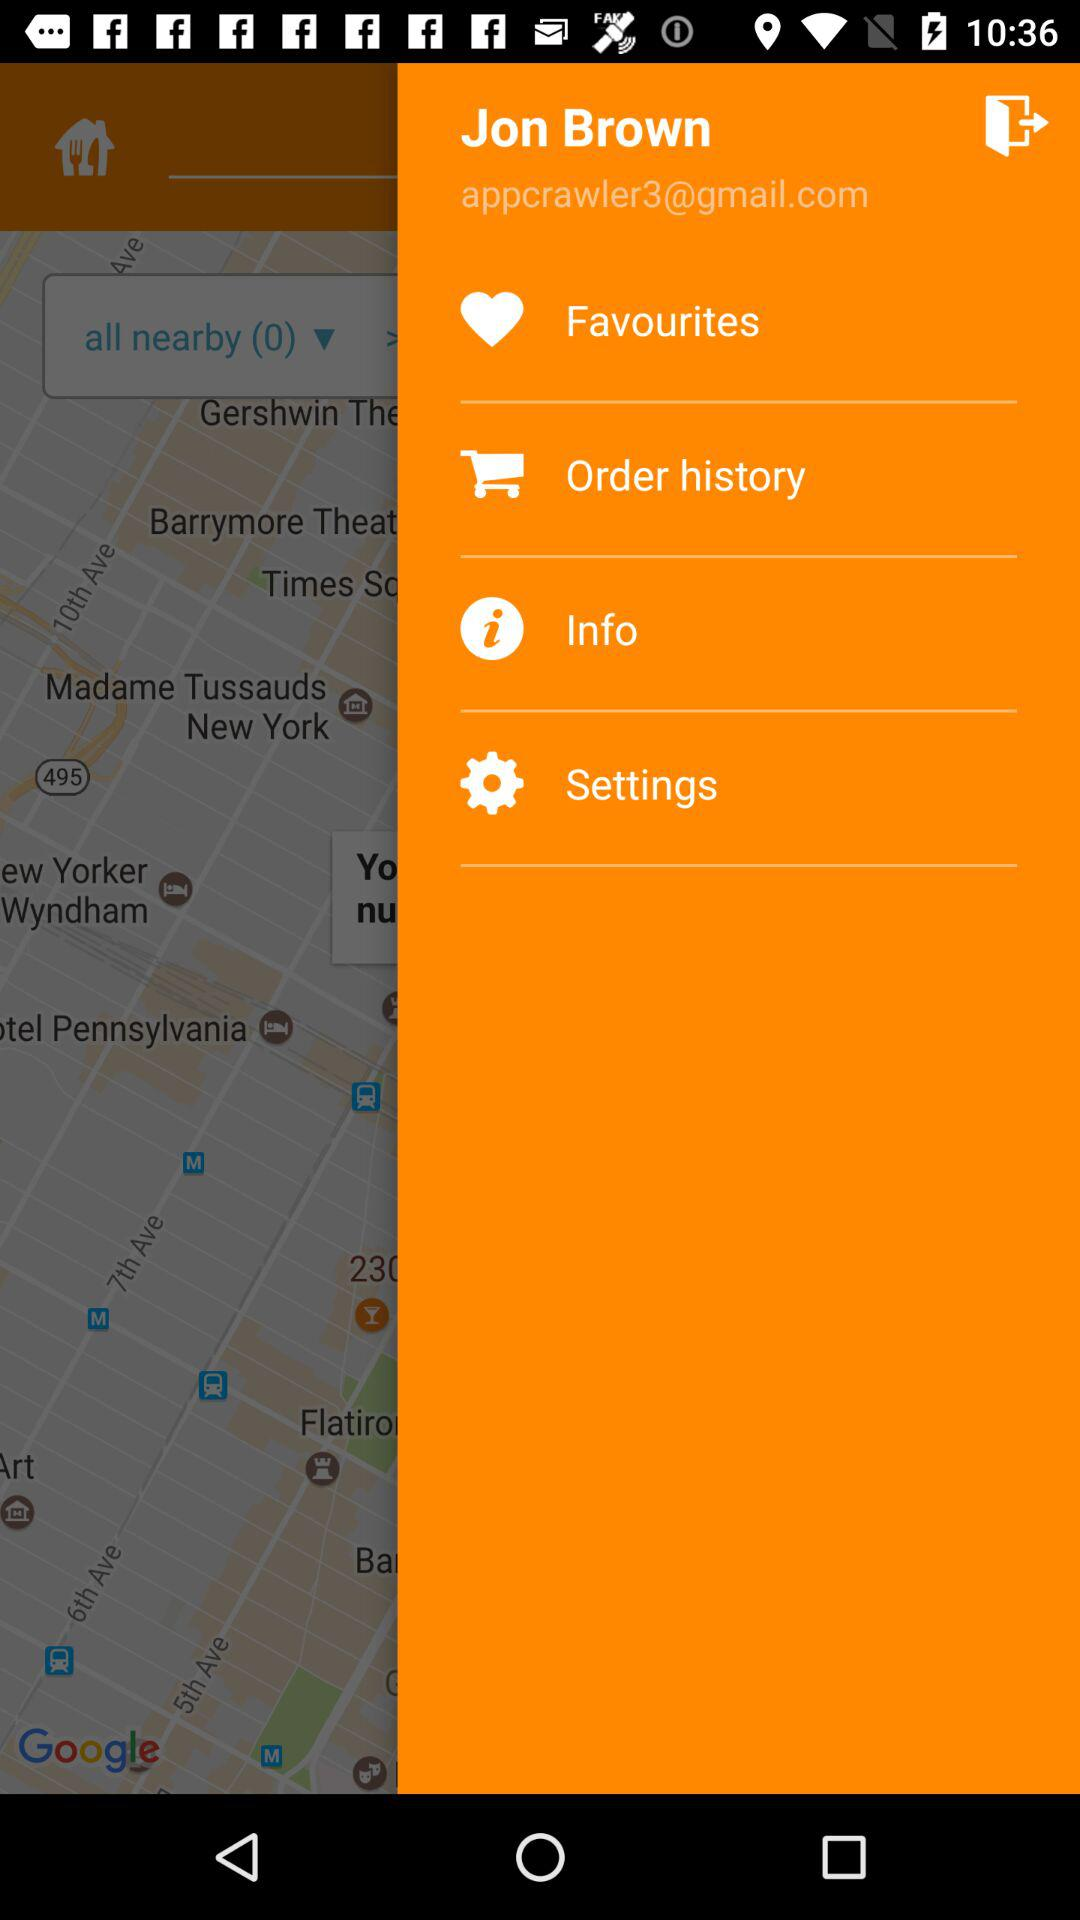How many email addresses are there in the screen?
Answer the question using a single word or phrase. 1 